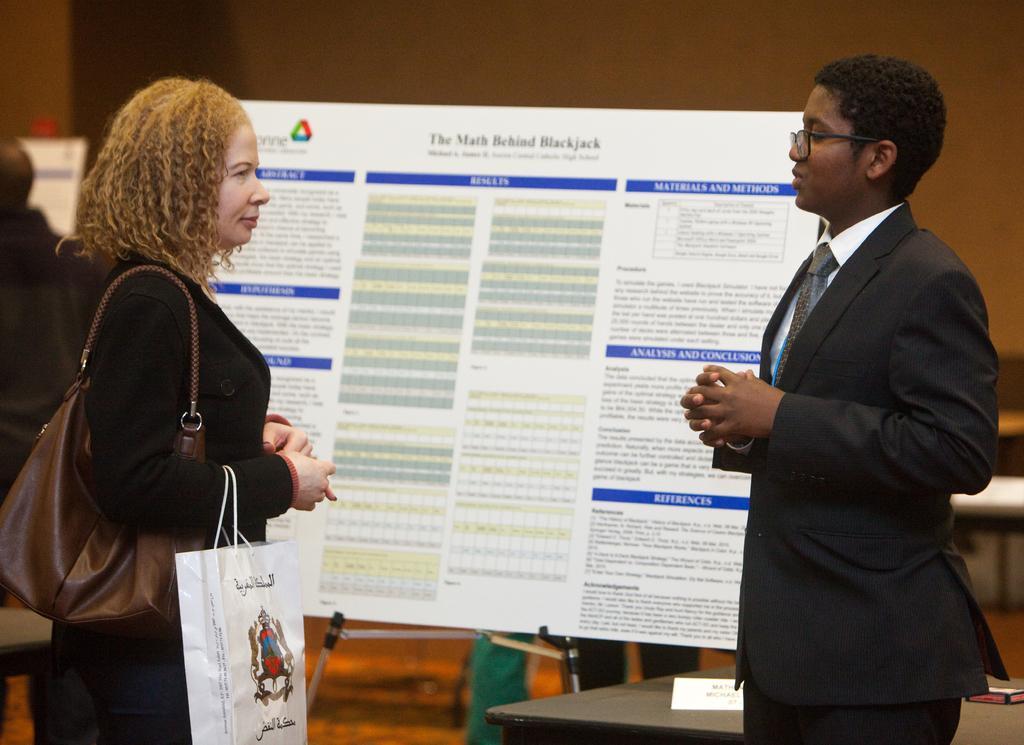How would you summarize this image in a sentence or two? In this image we can see women standing on the ground and one of them is holding paper bag to the hands. In the background we can see information board and walls. 